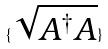<formula> <loc_0><loc_0><loc_500><loc_500>\{ \sqrt { A ^ { \dagger } A } \}</formula> 